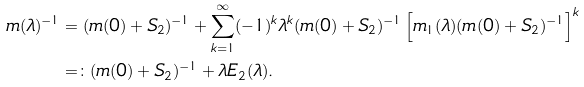Convert formula to latex. <formula><loc_0><loc_0><loc_500><loc_500>m ( \lambda ) ^ { - 1 } & = ( m ( 0 ) + S _ { 2 } ) ^ { - 1 } + \sum _ { k = 1 } ^ { \infty } ( - 1 ) ^ { k } \lambda ^ { k } ( m ( 0 ) + S _ { 2 } ) ^ { - 1 } \left [ m _ { 1 } ( \lambda ) ( m ( 0 ) + S _ { 2 } ) ^ { - 1 } \right ] ^ { k } \\ & = \colon ( m ( 0 ) + S _ { 2 } ) ^ { - 1 } + \lambda E _ { 2 } ( \lambda ) .</formula> 